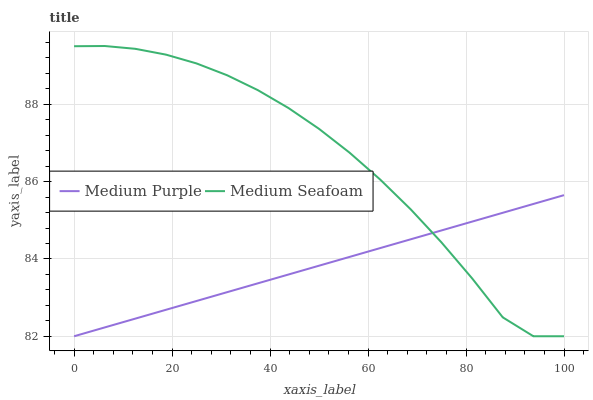Does Medium Purple have the minimum area under the curve?
Answer yes or no. Yes. Does Medium Seafoam have the maximum area under the curve?
Answer yes or no. Yes. Does Medium Seafoam have the minimum area under the curve?
Answer yes or no. No. Is Medium Purple the smoothest?
Answer yes or no. Yes. Is Medium Seafoam the roughest?
Answer yes or no. Yes. Is Medium Seafoam the smoothest?
Answer yes or no. No. 